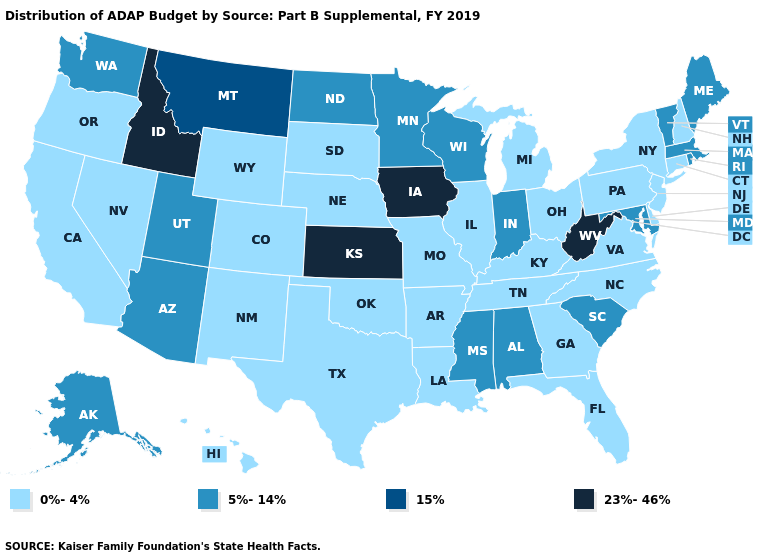Does Minnesota have a higher value than Kansas?
Keep it brief. No. Does the first symbol in the legend represent the smallest category?
Quick response, please. Yes. What is the highest value in the MidWest ?
Short answer required. 23%-46%. Does the map have missing data?
Short answer required. No. Name the states that have a value in the range 0%-4%?
Short answer required. Arkansas, California, Colorado, Connecticut, Delaware, Florida, Georgia, Hawaii, Illinois, Kentucky, Louisiana, Michigan, Missouri, Nebraska, Nevada, New Hampshire, New Jersey, New Mexico, New York, North Carolina, Ohio, Oklahoma, Oregon, Pennsylvania, South Dakota, Tennessee, Texas, Virginia, Wyoming. Is the legend a continuous bar?
Quick response, please. No. Among the states that border Vermont , which have the lowest value?
Concise answer only. New Hampshire, New York. Among the states that border Maine , which have the lowest value?
Concise answer only. New Hampshire. What is the highest value in states that border Mississippi?
Write a very short answer. 5%-14%. What is the value of Virginia?
Give a very brief answer. 0%-4%. What is the value of Maine?
Answer briefly. 5%-14%. How many symbols are there in the legend?
Concise answer only. 4. What is the value of California?
Be succinct. 0%-4%. What is the highest value in the USA?
Short answer required. 23%-46%. 